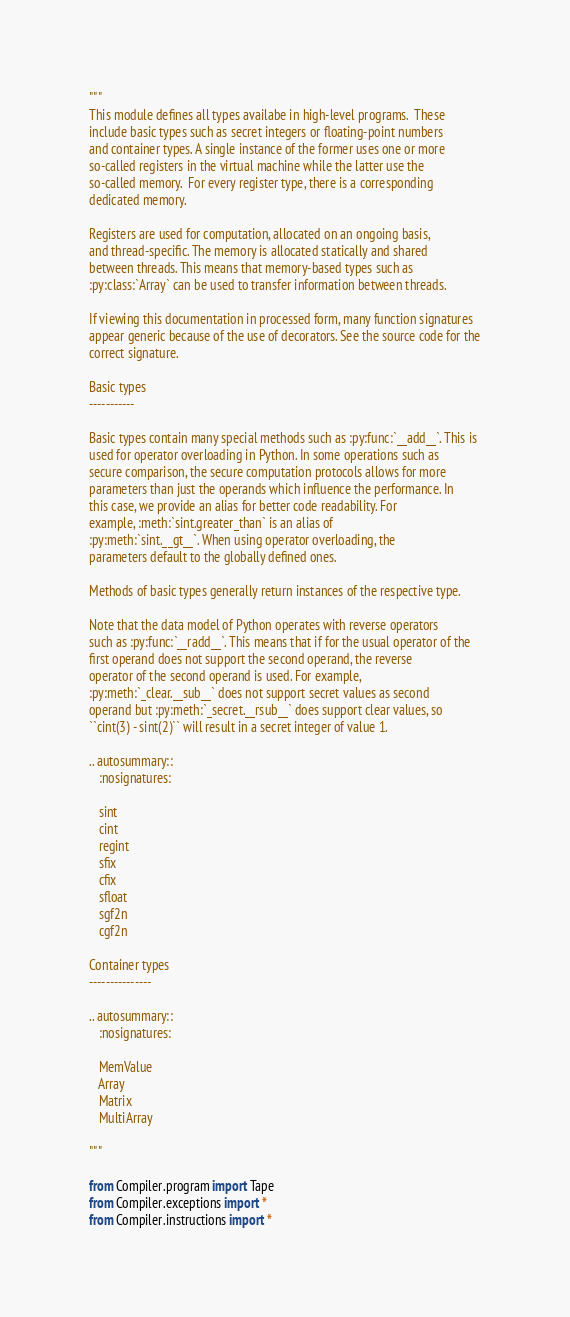<code> <loc_0><loc_0><loc_500><loc_500><_Python_>"""
This module defines all types availabe in high-level programs.  These
include basic types such as secret integers or floating-point numbers
and container types. A single instance of the former uses one or more
so-called registers in the virtual machine while the latter use the
so-called memory.  For every register type, there is a corresponding
dedicated memory.

Registers are used for computation, allocated on an ongoing basis,
and thread-specific. The memory is allocated statically and shared
between threads. This means that memory-based types such as
:py:class:`Array` can be used to transfer information between threads.

If viewing this documentation in processed form, many function signatures
appear generic because of the use of decorators. See the source code for the
correct signature.

Basic types
-----------

Basic types contain many special methods such as :py:func:`__add__`. This is
used for operator overloading in Python. In some operations such as
secure comparison, the secure computation protocols allows for more
parameters than just the operands which influence the performance. In
this case, we provide an alias for better code readability. For
example, :meth:`sint.greater_than` is an alias of
:py:meth:`sint.__gt__`. When using operator overloading, the
parameters default to the globally defined ones.

Methods of basic types generally return instances of the respective type.

Note that the data model of Python operates with reverse operators
such as :py:func:`__radd__`. This means that if for the usual operator of the
first operand does not support the second operand, the reverse
operator of the second operand is used. For example,
:py:meth:`_clear.__sub__` does not support secret values as second
operand but :py:meth:`_secret.__rsub__` does support clear values, so
``cint(3) - sint(2)`` will result in a secret integer of value 1.

.. autosummary::
   :nosignatures:

   sint
   cint
   regint
   sfix
   cfix
   sfloat
   sgf2n
   cgf2n

Container types
---------------

.. autosummary::
   :nosignatures:

   MemValue
   Array
   Matrix
   MultiArray

"""

from Compiler.program import Tape
from Compiler.exceptions import *
from Compiler.instructions import *</code> 